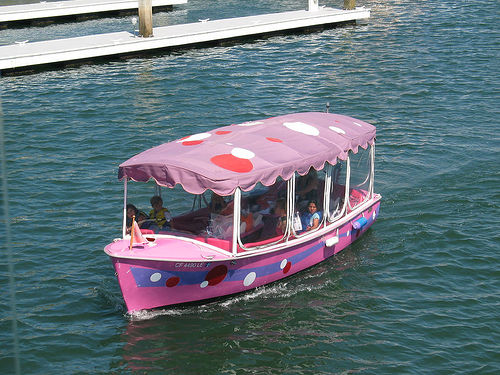What is unusual about the boat in this image? The boat immediately stands out due to its whimsical design. It appears to be themed after a famous mushroom power-up from a popular video game franchise, with a bright pink base color and large white spots. This unusual design is likely to attract attention and provide a fun experience for passengers. 